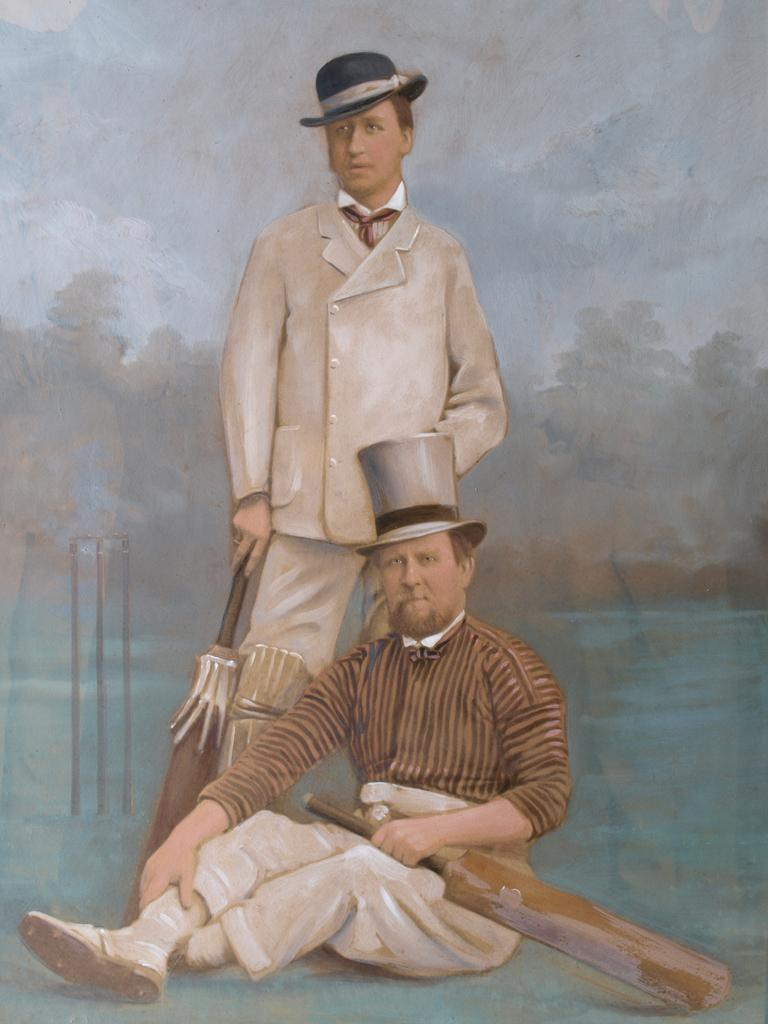How many people are depicted in the painting? There are two persons in the painting. What are the persons wearing on their heads? The persons are wearing hats. What objects are the persons holding in the painting? The persons are holding bats. What can be seen in the background of the painting? There is a wicket, trees, and the sky visible in the background of the painting. What type of bait is being used by the person on the left in the painting? There is no bait present in the painting; the persons are holding bats, which are typically used in sports like cricket or baseball. 